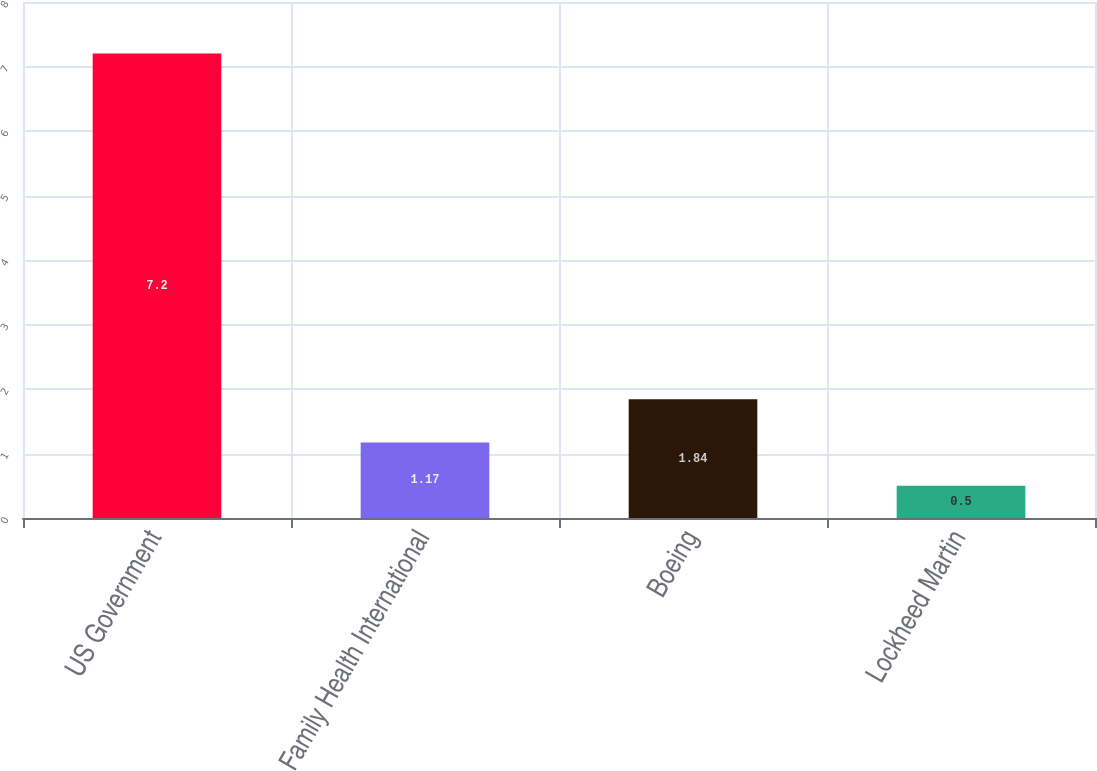<chart> <loc_0><loc_0><loc_500><loc_500><bar_chart><fcel>US Government<fcel>Family Health International<fcel>Boeing<fcel>Lockheed Martin<nl><fcel>7.2<fcel>1.17<fcel>1.84<fcel>0.5<nl></chart> 